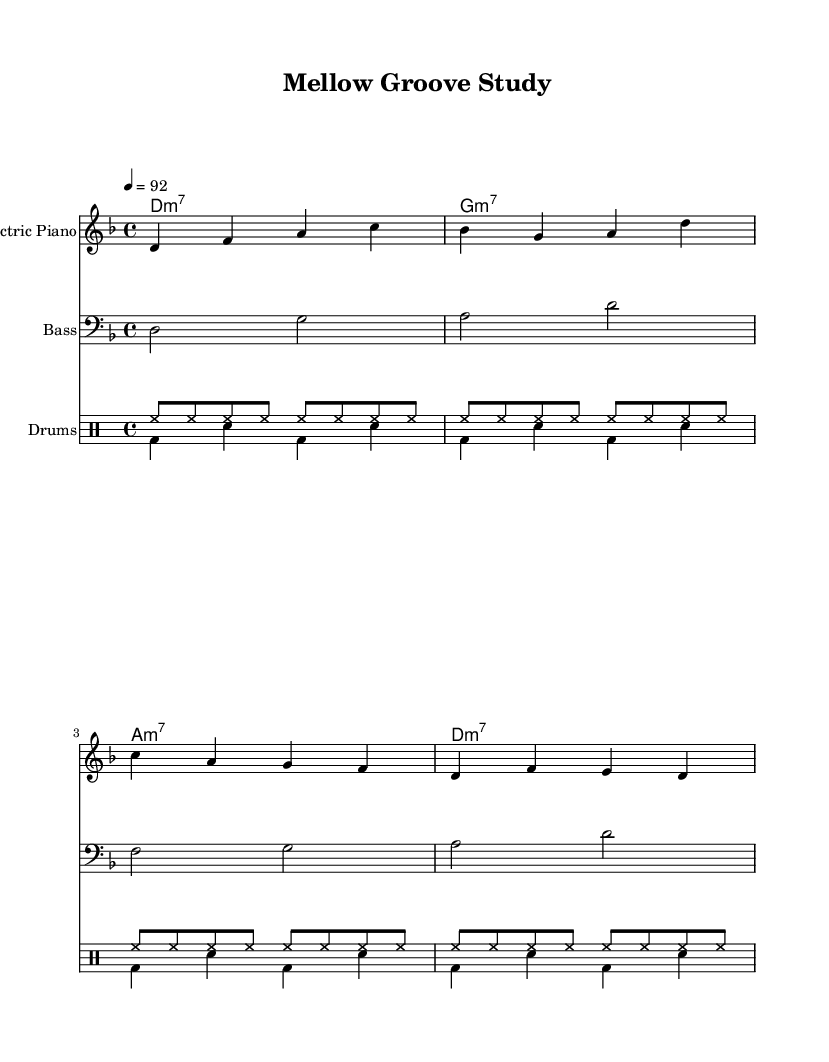What is the key signature of this music? The key signature is D minor, which has one flat (B flat). You can tell this by looking at the beginning of the staff where the key signature is indicated with a flat symbol.
Answer: D minor What is the time signature of this music? The time signature is 4/4, which indicates that there are four beats in each measure and a quarter note receives one beat. This can be seen at the start of the piece where the time signature is displayed.
Answer: 4/4 What is the tempo marking in this piece? The tempo marking is "4 = 92", meaning there are 92 beats per minute, with each beat represented by a quarter note. This is typically found at the beginning of the score near the global settings.
Answer: 92 How many measures are in the Electric Piano part? The Electric Piano part contains 4 measures, as counted by the vertical bar lines separating each measure in the staff.
Answer: 4 What types of chords are used in the rhythm guitar part? The rhythm guitar part features minor seventh chords, which can be identified by the "m7" notation following the chord root names (D, G, A) written above the staff.
Answer: minor seventh How is the drum pattern structured in this piece? The drum pattern consists of a consistent hi-hat rhythm played throughout, paired with a bass drum and snare hits, creating a syncopated feel typical in funk music. This structure can be analyzed by observing the rhythmic placement of the different drum sounds in both the up and down parts.
Answer: syncopated What is the distinct style of this compositional work? The style is funk, characterized by its groove-oriented and rhythmic feel, commonly featuring tight instrumentation and syncopation. This is inferred from the instruments used and the laid-back feel present in the score.
Answer: funk 